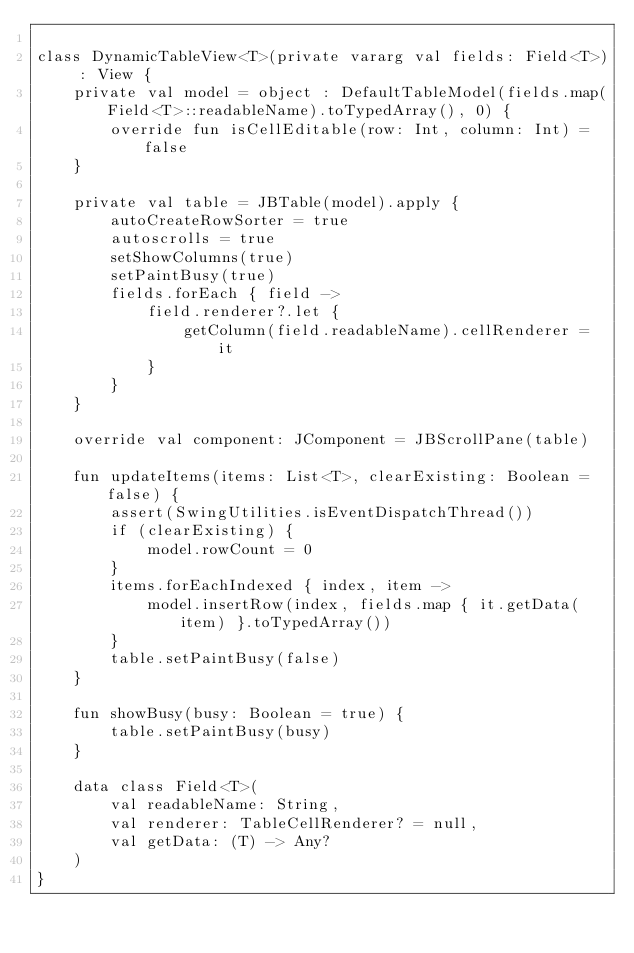Convert code to text. <code><loc_0><loc_0><loc_500><loc_500><_Kotlin_>
class DynamicTableView<T>(private vararg val fields: Field<T>) : View {
    private val model = object : DefaultTableModel(fields.map(Field<T>::readableName).toTypedArray(), 0) {
        override fun isCellEditable(row: Int, column: Int) = false
    }

    private val table = JBTable(model).apply {
        autoCreateRowSorter = true
        autoscrolls = true
        setShowColumns(true)
        setPaintBusy(true)
        fields.forEach { field ->
            field.renderer?.let {
                getColumn(field.readableName).cellRenderer = it
            }
        }
    }

    override val component: JComponent = JBScrollPane(table)

    fun updateItems(items: List<T>, clearExisting: Boolean = false) {
        assert(SwingUtilities.isEventDispatchThread())
        if (clearExisting) {
            model.rowCount = 0
        }
        items.forEachIndexed { index, item ->
            model.insertRow(index, fields.map { it.getData(item) }.toTypedArray())
        }
        table.setPaintBusy(false)
    }

    fun showBusy(busy: Boolean = true) {
        table.setPaintBusy(busy)
    }

    data class Field<T>(
        val readableName: String,
        val renderer: TableCellRenderer? = null,
        val getData: (T) -> Any?
    )
}
</code> 